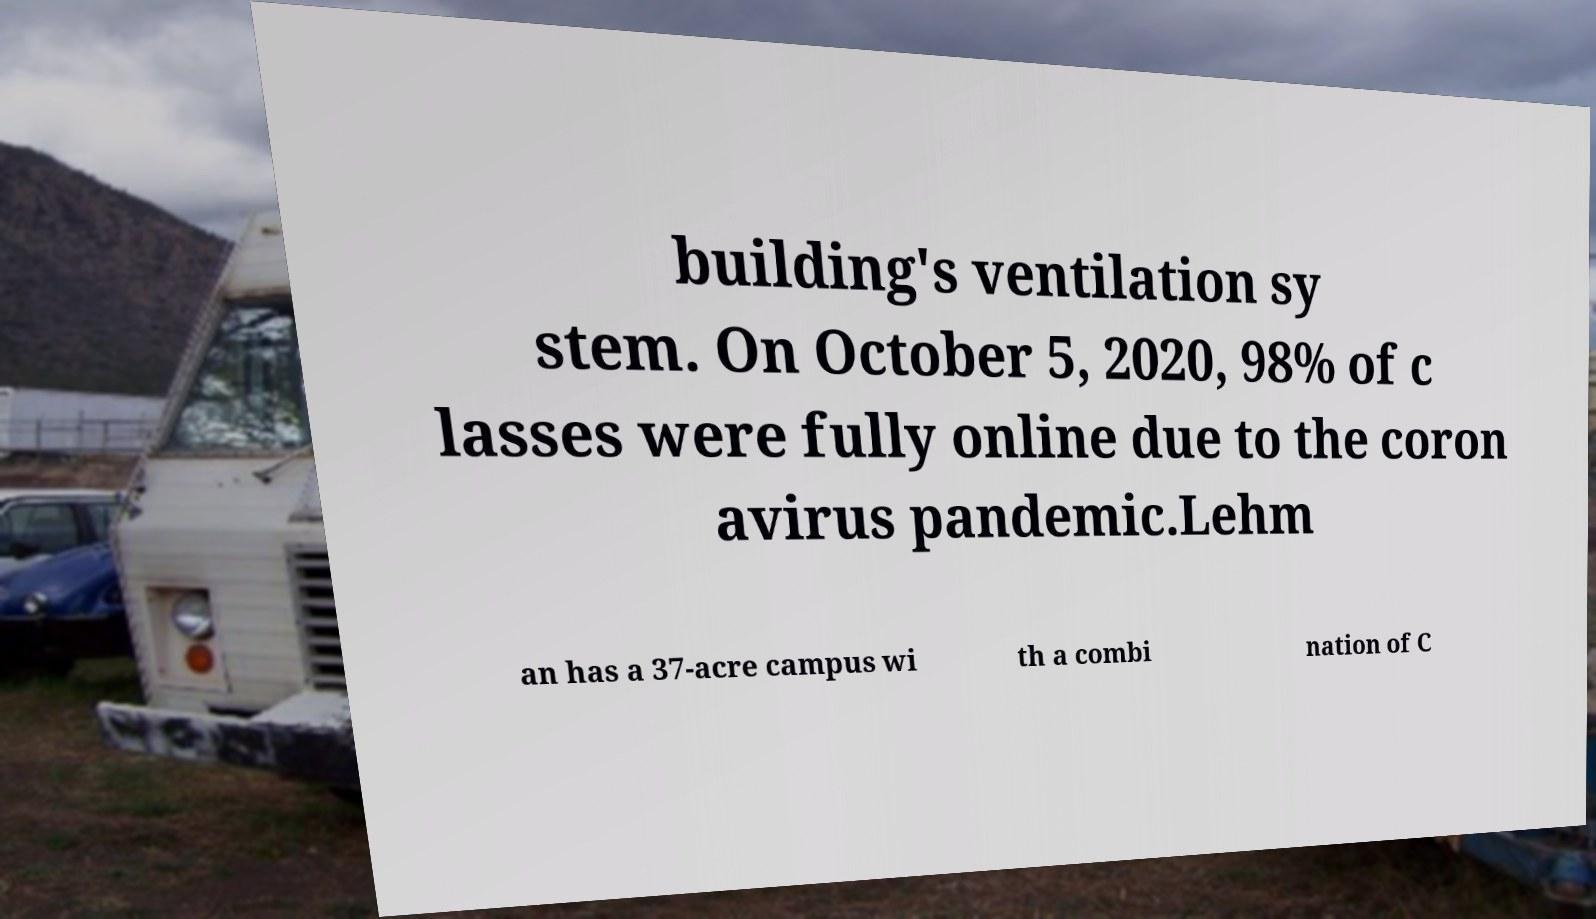Please identify and transcribe the text found in this image. building's ventilation sy stem. On October 5, 2020, 98% of c lasses were fully online due to the coron avirus pandemic.Lehm an has a 37-acre campus wi th a combi nation of C 